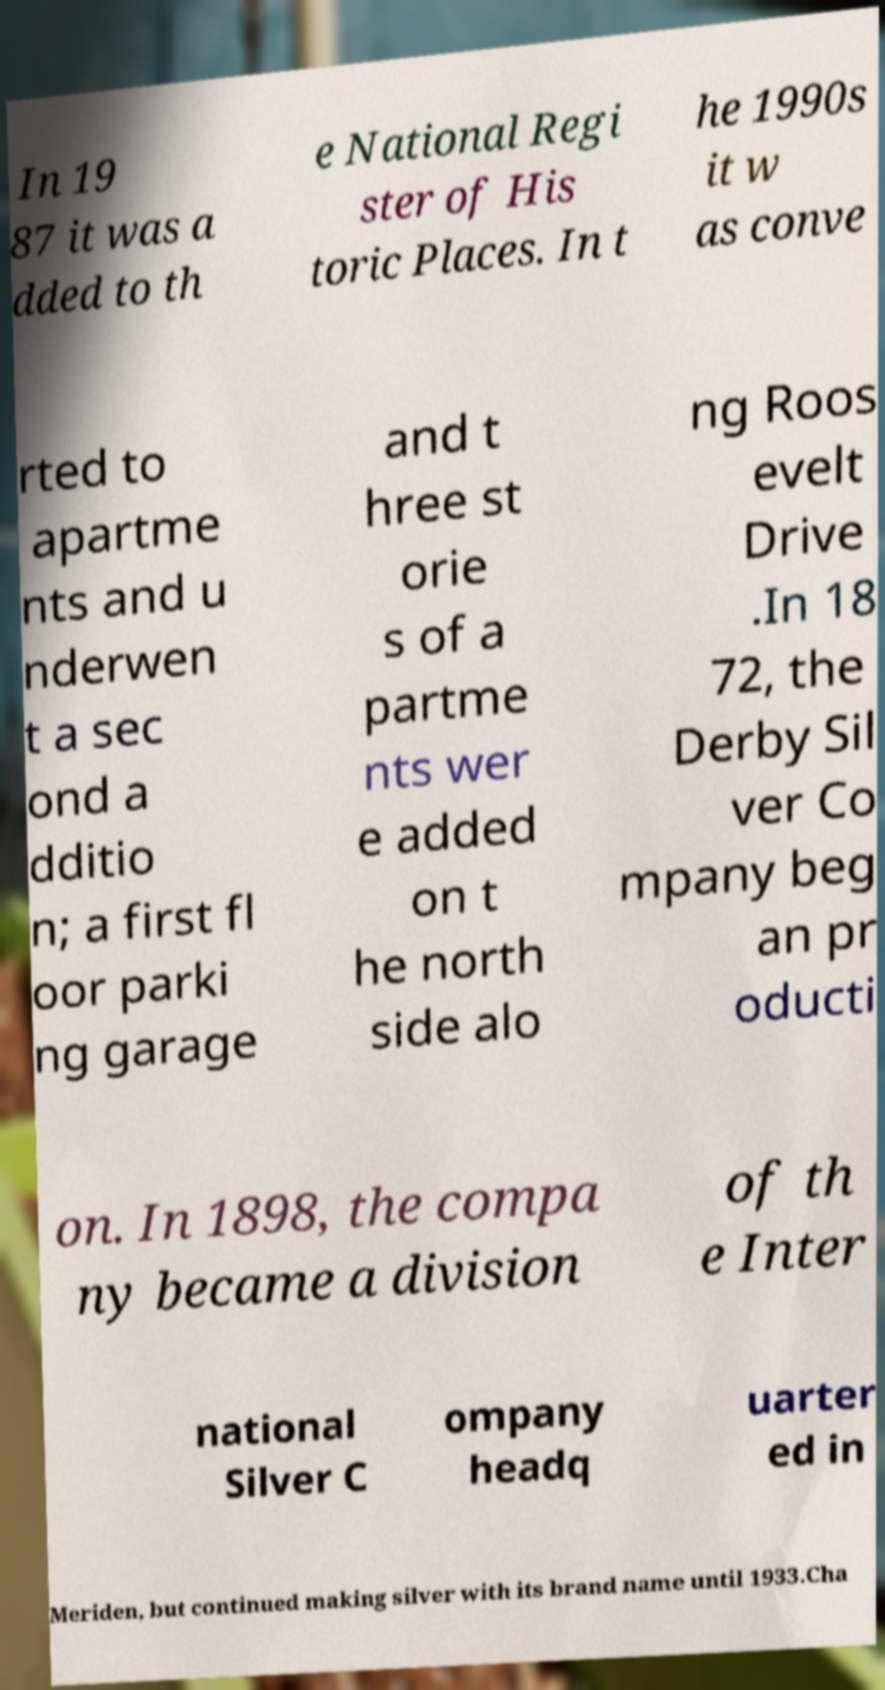Please read and relay the text visible in this image. What does it say? In 19 87 it was a dded to th e National Regi ster of His toric Places. In t he 1990s it w as conve rted to apartme nts and u nderwen t a sec ond a dditio n; a first fl oor parki ng garage and t hree st orie s of a partme nts wer e added on t he north side alo ng Roos evelt Drive .In 18 72, the Derby Sil ver Co mpany beg an pr oducti on. In 1898, the compa ny became a division of th e Inter national Silver C ompany headq uarter ed in Meriden, but continued making silver with its brand name until 1933.Cha 